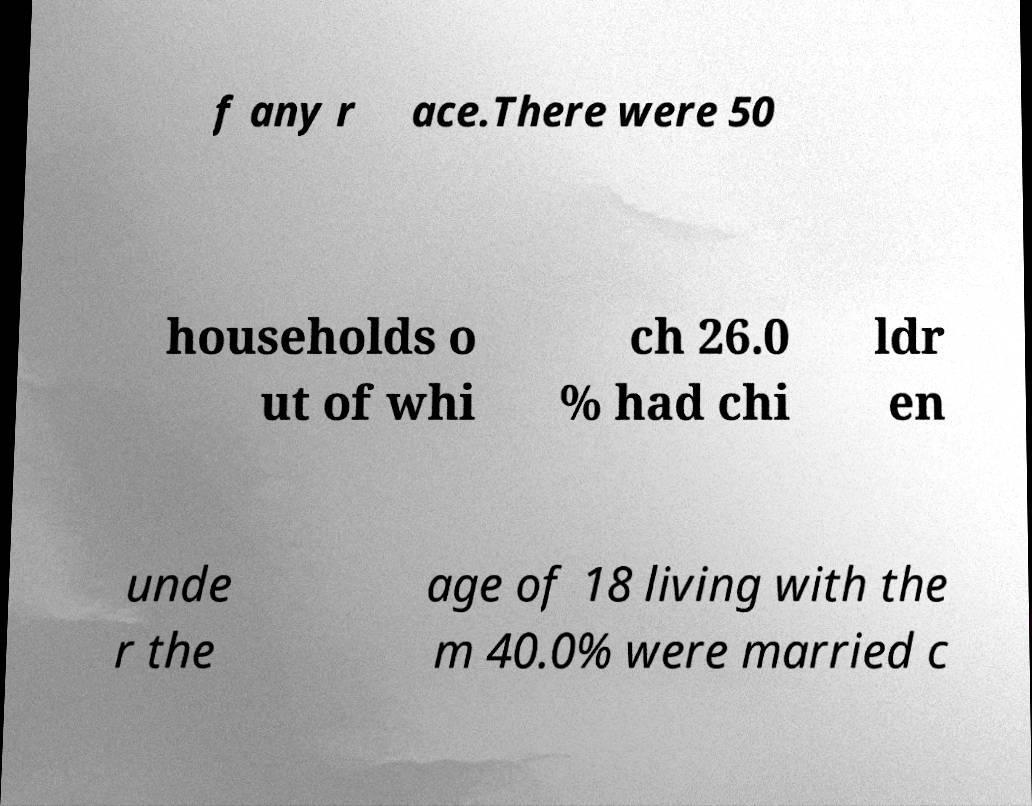Could you extract and type out the text from this image? f any r ace.There were 50 households o ut of whi ch 26.0 % had chi ldr en unde r the age of 18 living with the m 40.0% were married c 